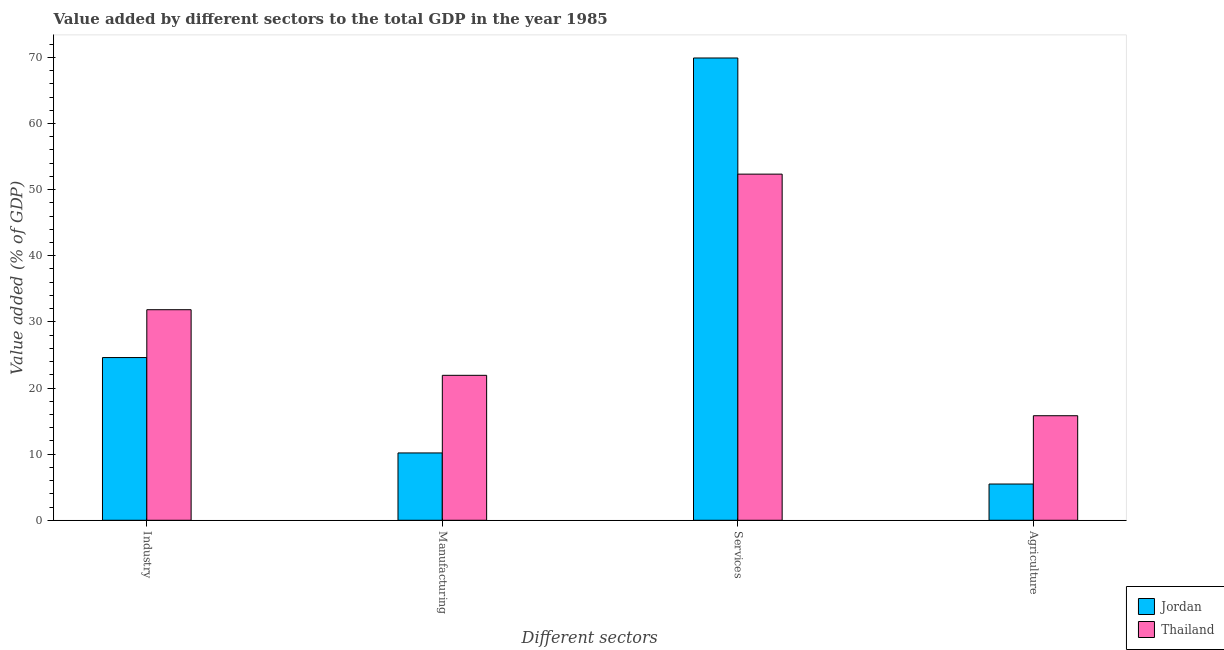How many different coloured bars are there?
Offer a terse response. 2. How many groups of bars are there?
Provide a short and direct response. 4. What is the label of the 4th group of bars from the left?
Offer a terse response. Agriculture. What is the value added by industrial sector in Thailand?
Give a very brief answer. 31.84. Across all countries, what is the maximum value added by agricultural sector?
Provide a succinct answer. 15.81. Across all countries, what is the minimum value added by industrial sector?
Your answer should be very brief. 24.61. In which country was the value added by industrial sector maximum?
Provide a short and direct response. Thailand. In which country was the value added by agricultural sector minimum?
Your answer should be compact. Jordan. What is the total value added by services sector in the graph?
Provide a succinct answer. 122.26. What is the difference between the value added by manufacturing sector in Thailand and that in Jordan?
Make the answer very short. 11.74. What is the difference between the value added by manufacturing sector in Thailand and the value added by industrial sector in Jordan?
Provide a short and direct response. -2.69. What is the average value added by manufacturing sector per country?
Offer a very short reply. 16.05. What is the difference between the value added by industrial sector and value added by agricultural sector in Jordan?
Ensure brevity in your answer.  19.13. What is the ratio of the value added by agricultural sector in Jordan to that in Thailand?
Make the answer very short. 0.35. Is the difference between the value added by industrial sector in Thailand and Jordan greater than the difference between the value added by agricultural sector in Thailand and Jordan?
Ensure brevity in your answer.  No. What is the difference between the highest and the second highest value added by agricultural sector?
Your response must be concise. 10.33. What is the difference between the highest and the lowest value added by industrial sector?
Make the answer very short. 7.24. In how many countries, is the value added by manufacturing sector greater than the average value added by manufacturing sector taken over all countries?
Provide a succinct answer. 1. Is the sum of the value added by agricultural sector in Jordan and Thailand greater than the maximum value added by manufacturing sector across all countries?
Offer a very short reply. No. Is it the case that in every country, the sum of the value added by services sector and value added by agricultural sector is greater than the sum of value added by manufacturing sector and value added by industrial sector?
Offer a terse response. Yes. What does the 2nd bar from the left in Industry represents?
Ensure brevity in your answer.  Thailand. What does the 2nd bar from the right in Services represents?
Your answer should be very brief. Jordan. How many bars are there?
Provide a short and direct response. 8. How many countries are there in the graph?
Make the answer very short. 2. Are the values on the major ticks of Y-axis written in scientific E-notation?
Your response must be concise. No. How are the legend labels stacked?
Your response must be concise. Vertical. What is the title of the graph?
Provide a short and direct response. Value added by different sectors to the total GDP in the year 1985. Does "Cuba" appear as one of the legend labels in the graph?
Your response must be concise. No. What is the label or title of the X-axis?
Offer a very short reply. Different sectors. What is the label or title of the Y-axis?
Provide a short and direct response. Value added (% of GDP). What is the Value added (% of GDP) of Jordan in Industry?
Make the answer very short. 24.61. What is the Value added (% of GDP) in Thailand in Industry?
Provide a succinct answer. 31.84. What is the Value added (% of GDP) of Jordan in Manufacturing?
Provide a short and direct response. 10.18. What is the Value added (% of GDP) of Thailand in Manufacturing?
Make the answer very short. 21.92. What is the Value added (% of GDP) in Jordan in Services?
Make the answer very short. 69.91. What is the Value added (% of GDP) in Thailand in Services?
Your answer should be compact. 52.35. What is the Value added (% of GDP) of Jordan in Agriculture?
Your answer should be compact. 5.48. What is the Value added (% of GDP) in Thailand in Agriculture?
Provide a short and direct response. 15.81. Across all Different sectors, what is the maximum Value added (% of GDP) of Jordan?
Ensure brevity in your answer.  69.91. Across all Different sectors, what is the maximum Value added (% of GDP) of Thailand?
Your answer should be compact. 52.35. Across all Different sectors, what is the minimum Value added (% of GDP) in Jordan?
Give a very brief answer. 5.48. Across all Different sectors, what is the minimum Value added (% of GDP) of Thailand?
Give a very brief answer. 15.81. What is the total Value added (% of GDP) of Jordan in the graph?
Make the answer very short. 110.18. What is the total Value added (% of GDP) in Thailand in the graph?
Your answer should be compact. 121.92. What is the difference between the Value added (% of GDP) in Jordan in Industry and that in Manufacturing?
Make the answer very short. 14.42. What is the difference between the Value added (% of GDP) in Thailand in Industry and that in Manufacturing?
Provide a succinct answer. 9.92. What is the difference between the Value added (% of GDP) of Jordan in Industry and that in Services?
Offer a terse response. -45.3. What is the difference between the Value added (% of GDP) of Thailand in Industry and that in Services?
Keep it short and to the point. -20.51. What is the difference between the Value added (% of GDP) of Jordan in Industry and that in Agriculture?
Offer a very short reply. 19.13. What is the difference between the Value added (% of GDP) of Thailand in Industry and that in Agriculture?
Provide a succinct answer. 16.03. What is the difference between the Value added (% of GDP) in Jordan in Manufacturing and that in Services?
Your response must be concise. -59.73. What is the difference between the Value added (% of GDP) of Thailand in Manufacturing and that in Services?
Your answer should be compact. -30.43. What is the difference between the Value added (% of GDP) in Jordan in Manufacturing and that in Agriculture?
Ensure brevity in your answer.  4.7. What is the difference between the Value added (% of GDP) of Thailand in Manufacturing and that in Agriculture?
Give a very brief answer. 6.11. What is the difference between the Value added (% of GDP) of Jordan in Services and that in Agriculture?
Keep it short and to the point. 64.43. What is the difference between the Value added (% of GDP) in Thailand in Services and that in Agriculture?
Provide a succinct answer. 36.54. What is the difference between the Value added (% of GDP) in Jordan in Industry and the Value added (% of GDP) in Thailand in Manufacturing?
Provide a short and direct response. 2.69. What is the difference between the Value added (% of GDP) in Jordan in Industry and the Value added (% of GDP) in Thailand in Services?
Keep it short and to the point. -27.74. What is the difference between the Value added (% of GDP) of Jordan in Industry and the Value added (% of GDP) of Thailand in Agriculture?
Provide a succinct answer. 8.8. What is the difference between the Value added (% of GDP) of Jordan in Manufacturing and the Value added (% of GDP) of Thailand in Services?
Offer a very short reply. -42.17. What is the difference between the Value added (% of GDP) of Jordan in Manufacturing and the Value added (% of GDP) of Thailand in Agriculture?
Your response must be concise. -5.63. What is the difference between the Value added (% of GDP) in Jordan in Services and the Value added (% of GDP) in Thailand in Agriculture?
Offer a terse response. 54.1. What is the average Value added (% of GDP) in Jordan per Different sectors?
Offer a very short reply. 27.55. What is the average Value added (% of GDP) of Thailand per Different sectors?
Ensure brevity in your answer.  30.48. What is the difference between the Value added (% of GDP) in Jordan and Value added (% of GDP) in Thailand in Industry?
Keep it short and to the point. -7.24. What is the difference between the Value added (% of GDP) of Jordan and Value added (% of GDP) of Thailand in Manufacturing?
Offer a terse response. -11.74. What is the difference between the Value added (% of GDP) in Jordan and Value added (% of GDP) in Thailand in Services?
Your answer should be compact. 17.56. What is the difference between the Value added (% of GDP) in Jordan and Value added (% of GDP) in Thailand in Agriculture?
Make the answer very short. -10.33. What is the ratio of the Value added (% of GDP) in Jordan in Industry to that in Manufacturing?
Provide a short and direct response. 2.42. What is the ratio of the Value added (% of GDP) of Thailand in Industry to that in Manufacturing?
Keep it short and to the point. 1.45. What is the ratio of the Value added (% of GDP) in Jordan in Industry to that in Services?
Provide a short and direct response. 0.35. What is the ratio of the Value added (% of GDP) in Thailand in Industry to that in Services?
Your answer should be compact. 0.61. What is the ratio of the Value added (% of GDP) in Jordan in Industry to that in Agriculture?
Offer a very short reply. 4.49. What is the ratio of the Value added (% of GDP) of Thailand in Industry to that in Agriculture?
Make the answer very short. 2.01. What is the ratio of the Value added (% of GDP) in Jordan in Manufacturing to that in Services?
Offer a very short reply. 0.15. What is the ratio of the Value added (% of GDP) in Thailand in Manufacturing to that in Services?
Provide a short and direct response. 0.42. What is the ratio of the Value added (% of GDP) in Jordan in Manufacturing to that in Agriculture?
Make the answer very short. 1.86. What is the ratio of the Value added (% of GDP) of Thailand in Manufacturing to that in Agriculture?
Offer a terse response. 1.39. What is the ratio of the Value added (% of GDP) of Jordan in Services to that in Agriculture?
Offer a very short reply. 12.75. What is the ratio of the Value added (% of GDP) in Thailand in Services to that in Agriculture?
Give a very brief answer. 3.31. What is the difference between the highest and the second highest Value added (% of GDP) of Jordan?
Make the answer very short. 45.3. What is the difference between the highest and the second highest Value added (% of GDP) of Thailand?
Ensure brevity in your answer.  20.51. What is the difference between the highest and the lowest Value added (% of GDP) in Jordan?
Your response must be concise. 64.43. What is the difference between the highest and the lowest Value added (% of GDP) of Thailand?
Keep it short and to the point. 36.54. 